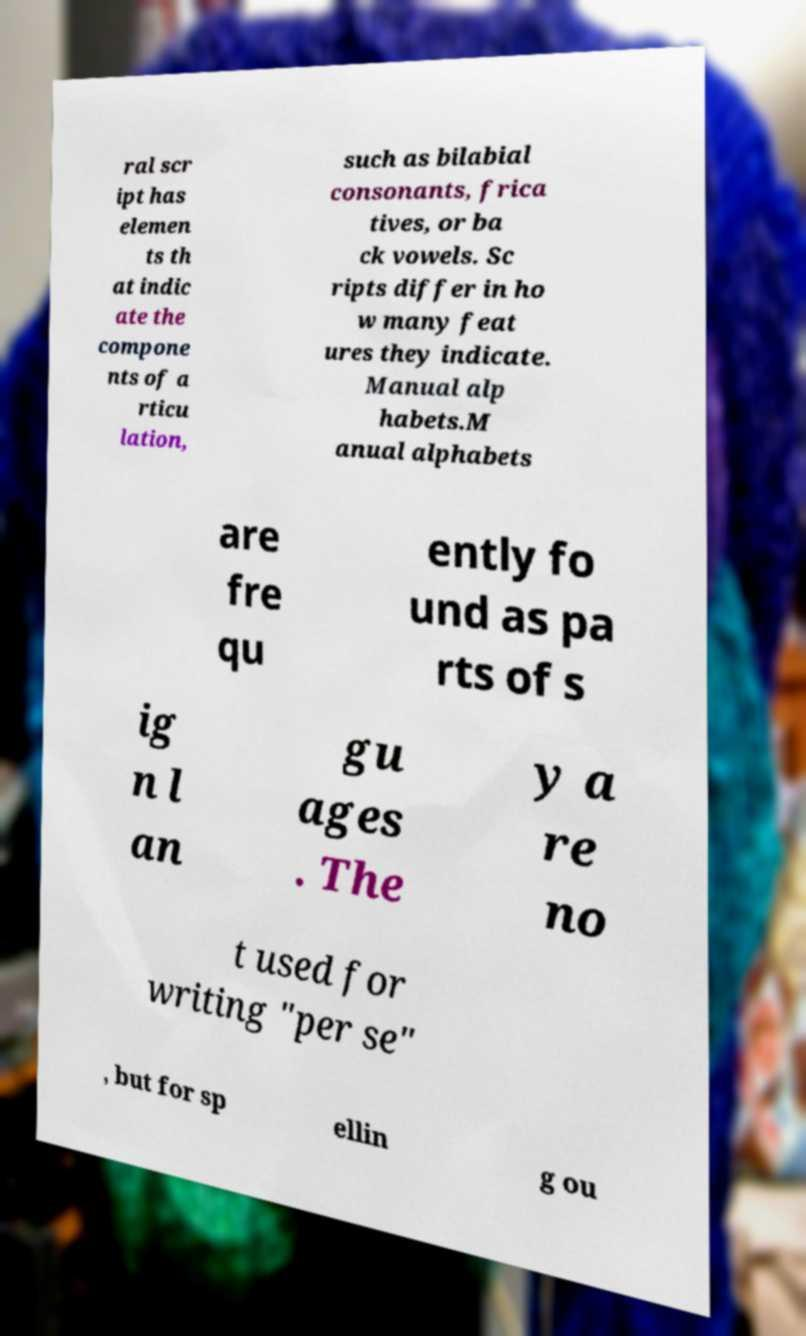For documentation purposes, I need the text within this image transcribed. Could you provide that? ral scr ipt has elemen ts th at indic ate the compone nts of a rticu lation, such as bilabial consonants, frica tives, or ba ck vowels. Sc ripts differ in ho w many feat ures they indicate. Manual alp habets.M anual alphabets are fre qu ently fo und as pa rts of s ig n l an gu ages . The y a re no t used for writing "per se" , but for sp ellin g ou 